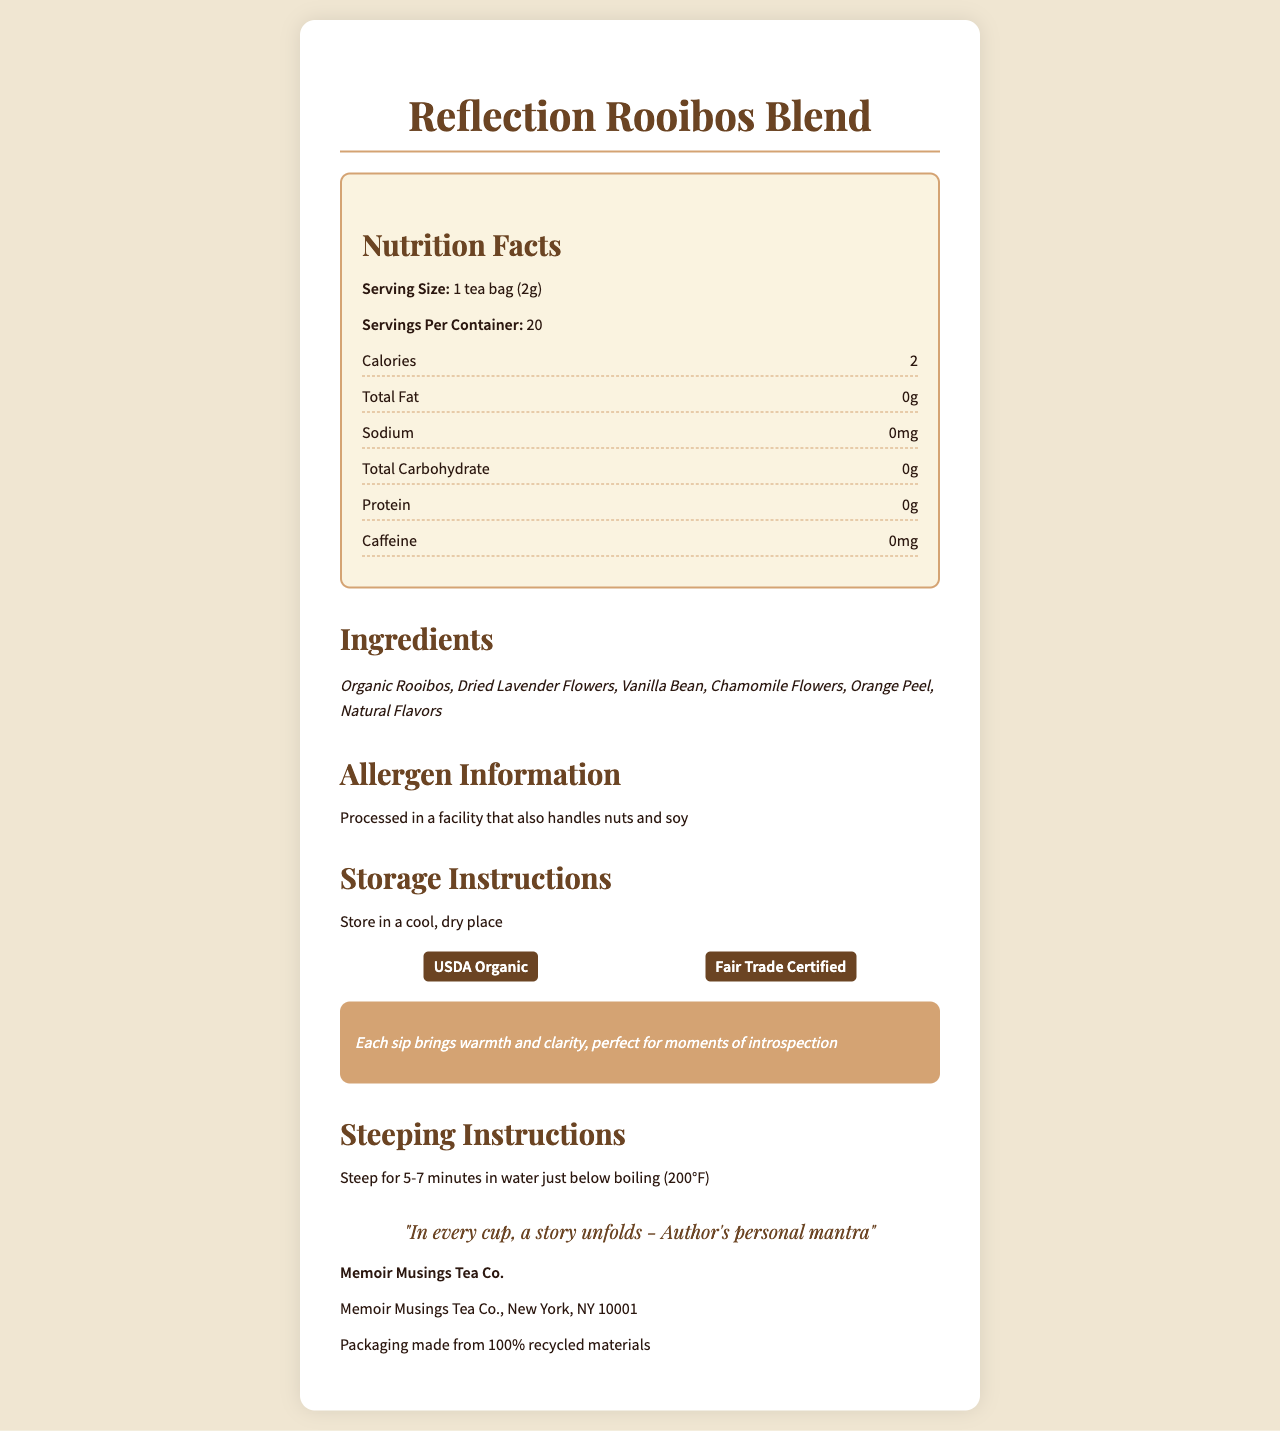what is the serving size of the Reflection Rooibos Blend? The serving size is specified in the document under Nutrition Facts.
Answer: 1 tea bag (2g) how many servings are there per container of Reflection Rooibos Blend? The document specifies that there are 20 servings per container.
Answer: 20 what is the calorie content per serving of Reflection Rooibos Blend? The calorie content per serving is listed as 2 in the Nutrition Facts section.
Answer: 2 name any two ingredients in the Reflection Rooibos Blend? The document lists the ingredients, two of which are Organic Rooibos and Dried Lavender Flowers.
Answer: Organic Rooibos, Dried Lavender Flowers is there any caffeine in the Reflection Rooibos Blend? The document specifies that there is 0mg of caffeine per serving.
Answer: No which vitamin(s) does the Reflection Rooibos Blend provide? A. Vitamin A B. Vitamin C C. Both A and B D. None The document indicates that it provides 0% of both Vitamin A and Vitamin C.
Answer: D what certifications does the Reflection Rooibos Blend have? The certifications listed in the document are USDA Organic and Fair Trade Certified.
Answer: USDA Organic, Fair Trade Certified is there any protein in the Reflection Rooibos Blend? The document specifies 0g protein per serving.
Answer: No where is the Memoir Musings Tea Co. based? The document states the manufacturer information as Memoir Musings Tea Co., New York, NY 10001.
Answer: New York, NY 10001 can the allergen information be confirmed from the document? The document mentions that the product is processed in a facility that also handles nuts and soy.
Answer: Yes summarize the main idea of the document. The document includes nutritional facts, ingredient list, certifications, allergen information, and additional details designed to evoke an emotional connection with the tea blend.
Answer: The document provides detailed nutritional information, ingredients, certifications, and emotional description of the Reflection Rooibos Blend tea, crafted by Memoir Musings Tea Co. what are the storage instructions for the tea? The storage instructions in the document are to store the tea in a cool, dry place.
Answer: Store in a cool, dry place what should be the water temperature for steeping the Reflection Rooibos Blend? The steeping instructions specify the water should be just below boiling at 200°F.
Answer: 200°F (just below boiling) what percentage of packaging materials are recycled? The document notes the packaging is made from 100% recycled materials.
Answer: 100% who is the author of the inspirational quote on the document? The document attributes the quote to "Author's personal mantra" without specifying a name.
Answer: Unknown what does the emotional description suggest about drinking the Reflection Rooibos Blend? The emotional description mentions that each sip provides warmth and clarity, perfect for moments of introspection, and aids in reflection and memory recall.
Answer: It brings warmth, clarity, and aids in reflection and memory recall. does the Reflection Rooibos Blend contain any other carbs? The document specifies 0g of total carbohydrates per serving.
Answer: No who manufactures the Reflection Rooibos Blend? A. Healthy Teas Co. B. Memoir Musings Tea Co. C. Reflection Blends Inc. The document states that the tea is manufactured by Memoir Musings Tea Co. in New York, NY 10001.
Answer: B how many calories do you consume if you drink two servings? Each serving has 2 calories, so two servings would provide a total of 4 calories (2 calories x 2 servings).
Answer: 4 does the blend contain any orange peel? Yes/No The ingredients list confirms the presence of Orange Peel.
Answer: Yes how many grams of fat are there in one serving of the Reflection Rooibos Blend? The document states that there is 0g of total fat per serving.
Answer: 0g how long should you steep the Reflection Rooibos Blend for? The steeping instructions advise to steep the tea for 5-7 minutes.
Answer: 5-7 minutes what is the product name of the tea blend? The product name is specified at the beginning of the document.
Answer: Reflection Rooibos Blend 